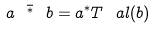<formula> <loc_0><loc_0><loc_500><loc_500>a \ \bar { ^ { * } } \ b = a ^ { * } T ^ { \ } a l ( b )</formula> 